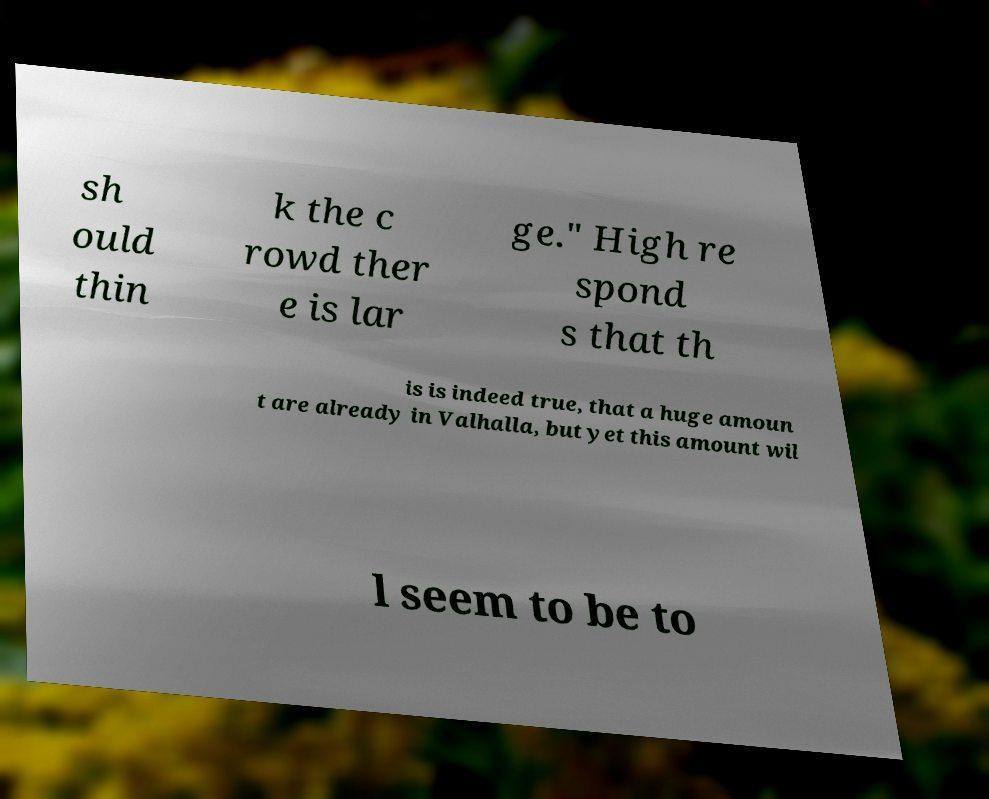Can you accurately transcribe the text from the provided image for me? sh ould thin k the c rowd ther e is lar ge." High re spond s that th is is indeed true, that a huge amoun t are already in Valhalla, but yet this amount wil l seem to be to 